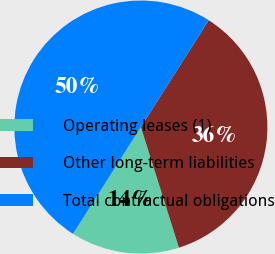<chart> <loc_0><loc_0><loc_500><loc_500><pie_chart><fcel>Operating leases (1)<fcel>Other long-term liabilities<fcel>Total contractual obligations<nl><fcel>13.88%<fcel>36.12%<fcel>50.0%<nl></chart> 